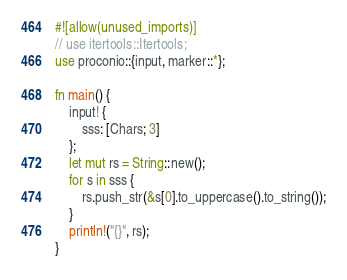<code> <loc_0><loc_0><loc_500><loc_500><_Rust_>#![allow(unused_imports)]
// use itertools::Itertools;
use proconio::{input, marker::*};

fn main() {
    input! {
        sss: [Chars; 3]
    };
    let mut rs = String::new();
    for s in sss {
        rs.push_str(&s[0].to_uppercase().to_string());
    }
    println!("{}", rs);
}
</code> 